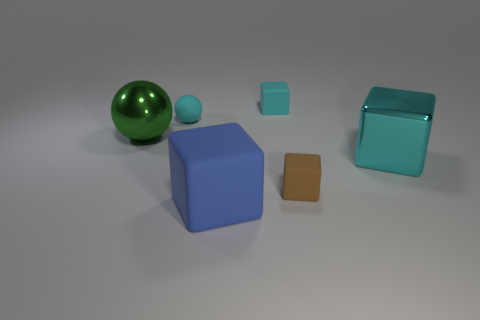Add 1 small green blocks. How many objects exist? 7 Subtract all spheres. How many objects are left? 4 Subtract all large yellow spheres. Subtract all big cubes. How many objects are left? 4 Add 2 cyan matte blocks. How many cyan matte blocks are left? 3 Add 4 brown spheres. How many brown spheres exist? 4 Subtract 0 blue cylinders. How many objects are left? 6 